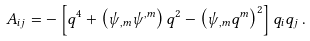Convert formula to latex. <formula><loc_0><loc_0><loc_500><loc_500>A _ { i j } = - \left [ q ^ { 4 } + \left ( \psi _ { , m } \psi ^ { , m } \right ) q ^ { 2 } - \left ( \psi _ { , m } q ^ { m } \right ) ^ { 2 } \right ] q _ { i } q _ { j } \, .</formula> 